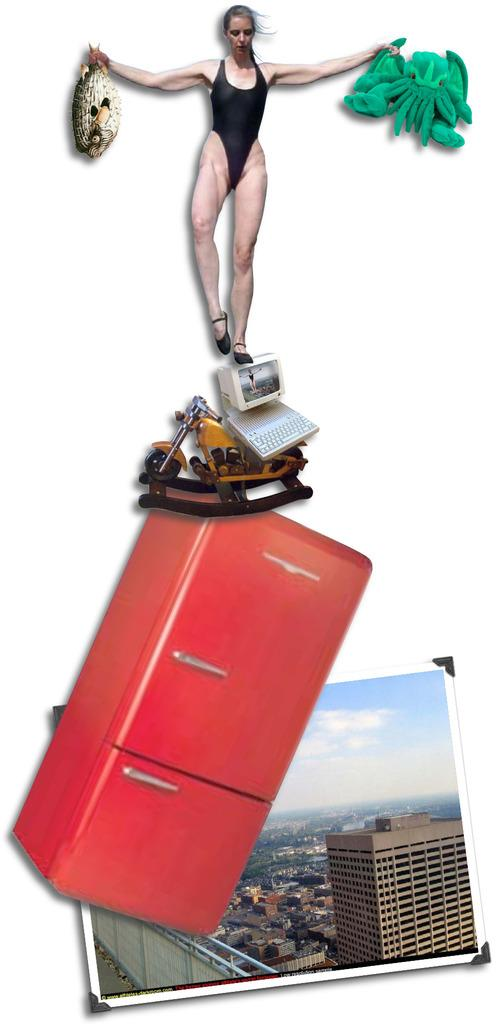What is the main subject of the image? There is a woman standing in the image. What is the woman holding in the image? The woman is holding objects, but the specific objects are not mentioned in the facts. What electronic devices are visible in the image? There is a monitor and a keyboard in the image. What type of decorative item can be seen in the image? There is a photo frame in the image. Are there any other objects visible in the image besides the ones mentioned? Yes, there are other unspecified objects in the image. How many oranges are being picked on the farm in the image? There is no mention of oranges, a farm, or any picking activity in the image. 